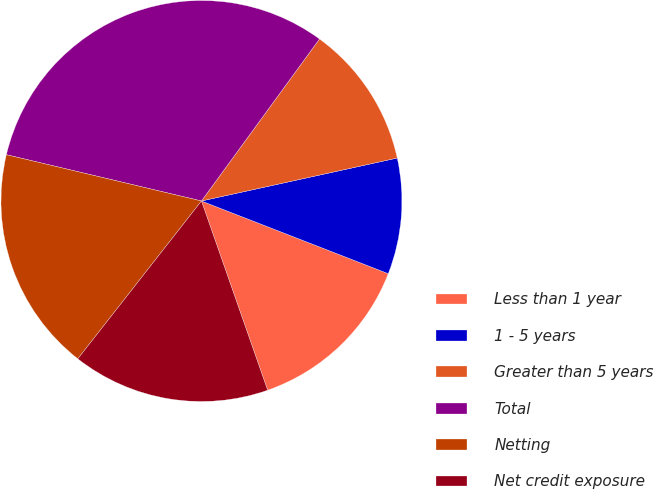Convert chart. <chart><loc_0><loc_0><loc_500><loc_500><pie_chart><fcel>Less than 1 year<fcel>1 - 5 years<fcel>Greater than 5 years<fcel>Total<fcel>Netting<fcel>Net credit exposure<nl><fcel>13.74%<fcel>9.34%<fcel>11.54%<fcel>31.31%<fcel>18.13%<fcel>15.93%<nl></chart> 